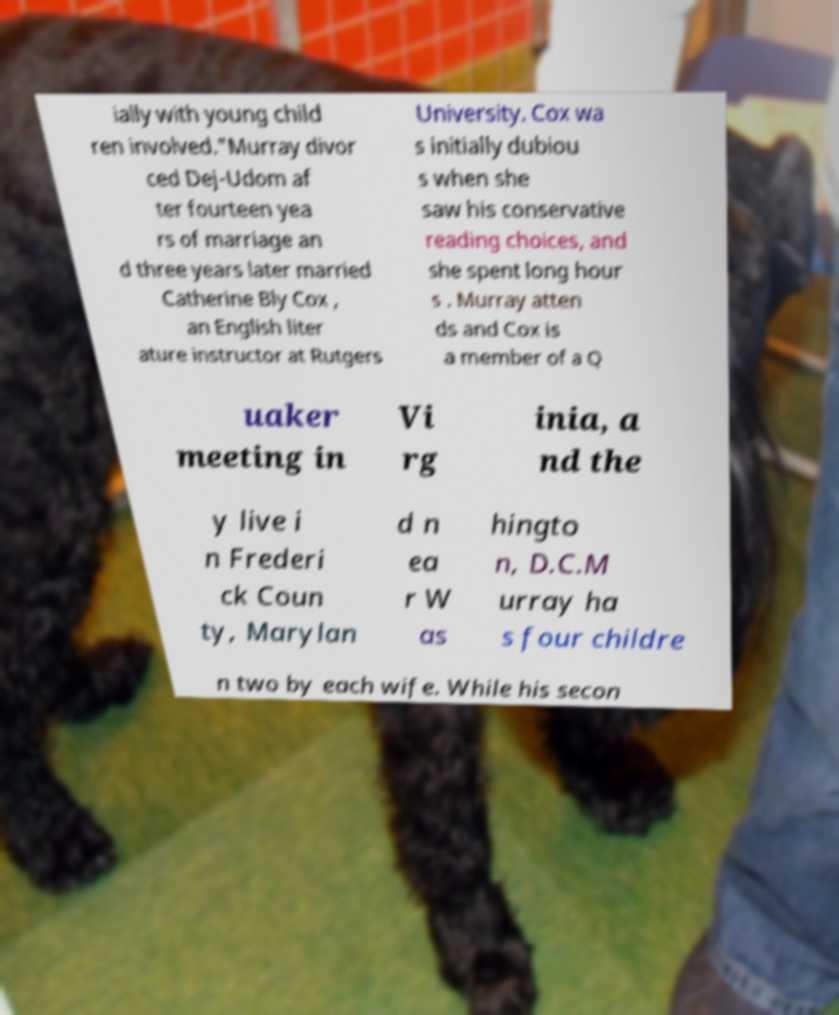Can you accurately transcribe the text from the provided image for me? ially with young child ren involved."Murray divor ced Dej-Udom af ter fourteen yea rs of marriage an d three years later married Catherine Bly Cox , an English liter ature instructor at Rutgers University. Cox wa s initially dubiou s when she saw his conservative reading choices, and she spent long hour s . Murray atten ds and Cox is a member of a Q uaker meeting in Vi rg inia, a nd the y live i n Frederi ck Coun ty, Marylan d n ea r W as hingto n, D.C.M urray ha s four childre n two by each wife. While his secon 